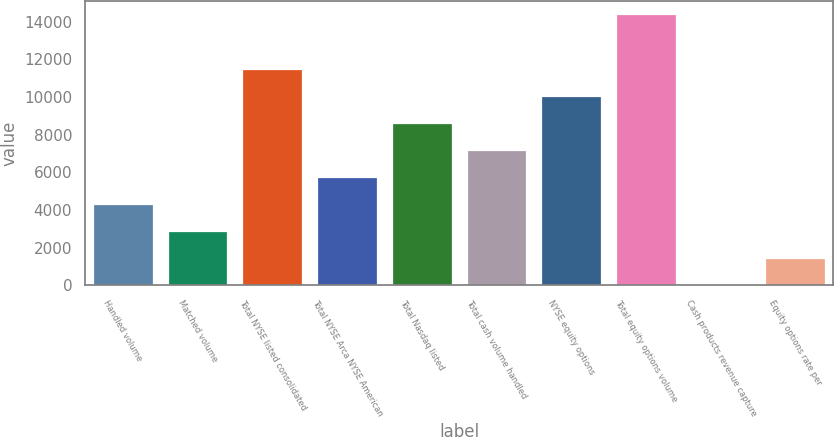Convert chart to OTSL. <chart><loc_0><loc_0><loc_500><loc_500><bar_chart><fcel>Handled volume<fcel>Matched volume<fcel>Total NYSE listed consolidated<fcel>Total NYSE Arca NYSE American<fcel>Total Nasdaq listed<fcel>Total cash volume handled<fcel>NYSE equity options<fcel>Total equity options volume<fcel>Cash products revenue capture<fcel>Equity options rate per<nl><fcel>4317.35<fcel>2878.25<fcel>11512.8<fcel>5756.45<fcel>8634.65<fcel>7195.55<fcel>10073.7<fcel>14391<fcel>0.05<fcel>1439.15<nl></chart> 